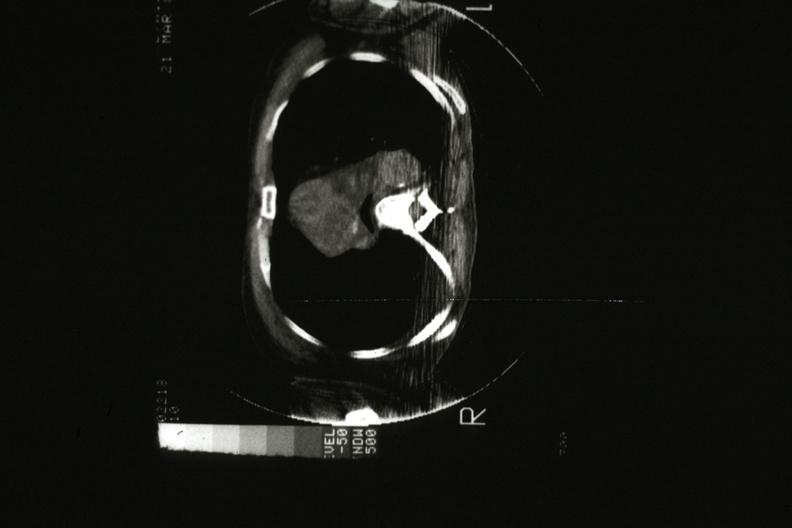what does this image show?
Answer the question using a single word or phrase. Cat scan showing tumor mass invading superior vena ca 